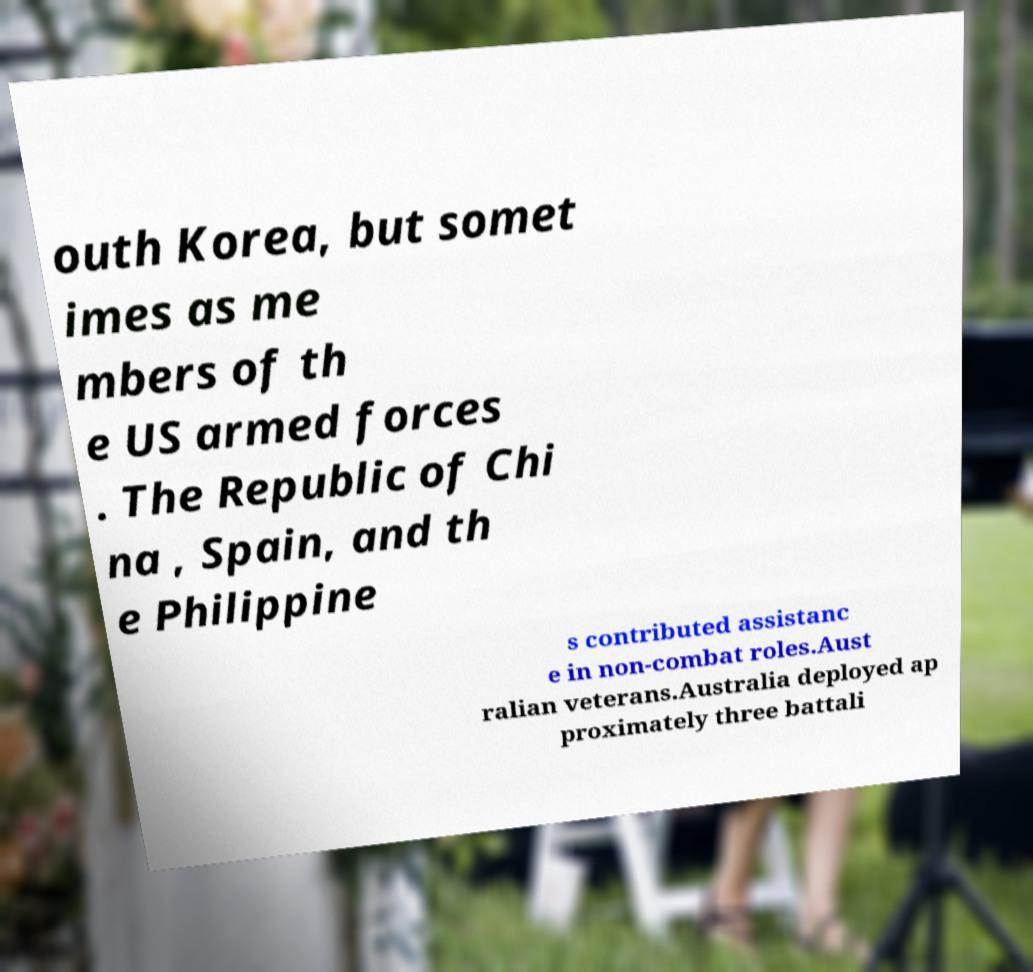I need the written content from this picture converted into text. Can you do that? outh Korea, but somet imes as me mbers of th e US armed forces . The Republic of Chi na , Spain, and th e Philippine s contributed assistanc e in non-combat roles.Aust ralian veterans.Australia deployed ap proximately three battali 